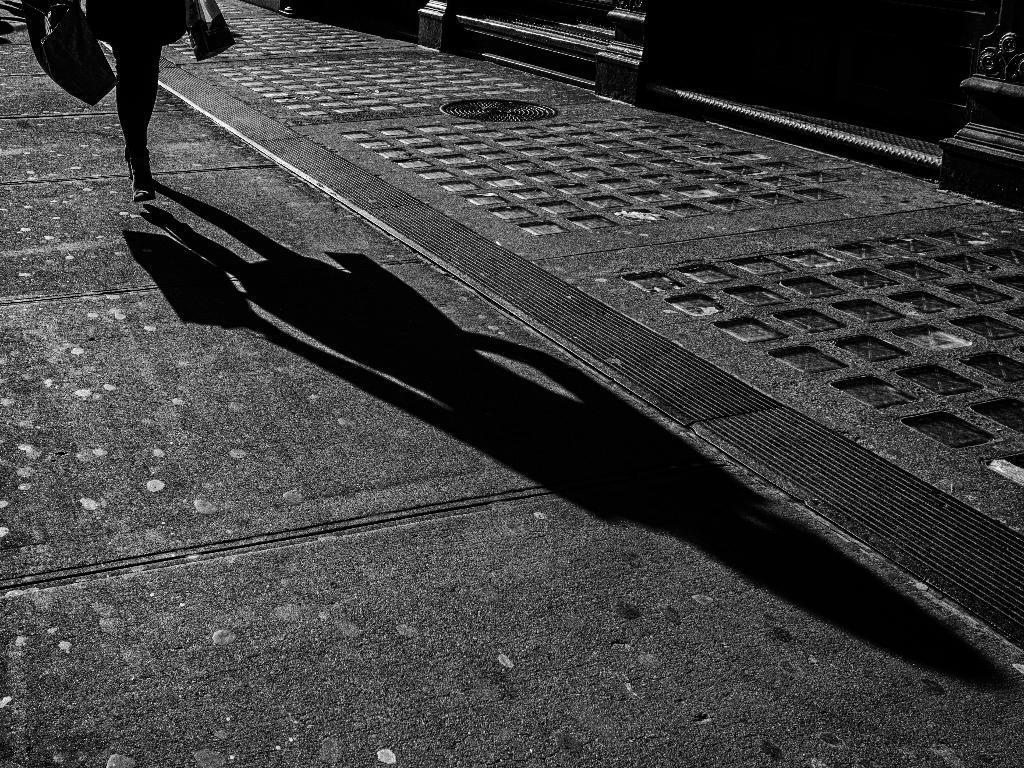Describe this image in one or two sentences. In this image we can see a person walking on the road and we can also see a shadow of the person. 